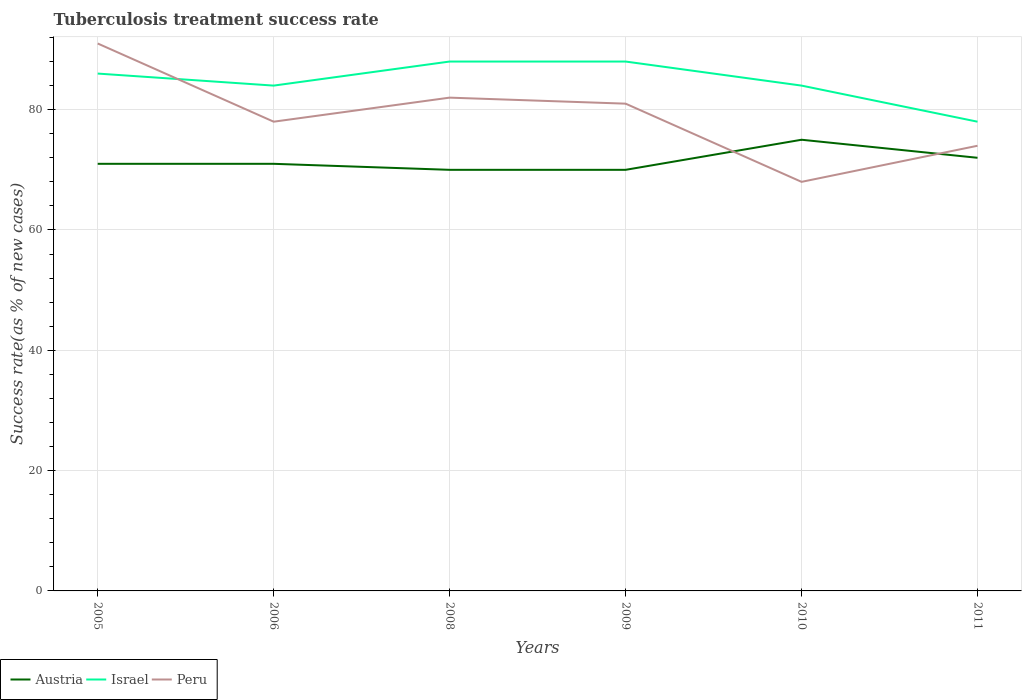How many different coloured lines are there?
Ensure brevity in your answer.  3. Does the line corresponding to Israel intersect with the line corresponding to Peru?
Your answer should be compact. Yes. Across all years, what is the maximum tuberculosis treatment success rate in Peru?
Offer a terse response. 68. In which year was the tuberculosis treatment success rate in Israel maximum?
Make the answer very short. 2011. What is the total tuberculosis treatment success rate in Peru in the graph?
Your answer should be compact. 23. What is the difference between the highest and the second highest tuberculosis treatment success rate in Israel?
Ensure brevity in your answer.  10. What is the difference between the highest and the lowest tuberculosis treatment success rate in Israel?
Ensure brevity in your answer.  3. Is the tuberculosis treatment success rate in Peru strictly greater than the tuberculosis treatment success rate in Israel over the years?
Offer a terse response. No. How many lines are there?
Make the answer very short. 3. How many years are there in the graph?
Offer a very short reply. 6. What is the difference between two consecutive major ticks on the Y-axis?
Make the answer very short. 20. Are the values on the major ticks of Y-axis written in scientific E-notation?
Offer a very short reply. No. Does the graph contain grids?
Provide a short and direct response. Yes. How are the legend labels stacked?
Offer a terse response. Horizontal. What is the title of the graph?
Give a very brief answer. Tuberculosis treatment success rate. What is the label or title of the Y-axis?
Keep it short and to the point. Success rate(as % of new cases). What is the Success rate(as % of new cases) of Peru in 2005?
Your response must be concise. 91. What is the Success rate(as % of new cases) of Peru in 2008?
Your response must be concise. 82. What is the Success rate(as % of new cases) in Austria in 2009?
Your response must be concise. 70. What is the Success rate(as % of new cases) in Israel in 2009?
Offer a terse response. 88. What is the Success rate(as % of new cases) in Austria in 2010?
Your response must be concise. 75. What is the Success rate(as % of new cases) of Israel in 2011?
Your response must be concise. 78. What is the Success rate(as % of new cases) of Peru in 2011?
Provide a succinct answer. 74. Across all years, what is the maximum Success rate(as % of new cases) in Austria?
Your response must be concise. 75. Across all years, what is the maximum Success rate(as % of new cases) of Peru?
Your answer should be very brief. 91. Across all years, what is the minimum Success rate(as % of new cases) in Austria?
Your answer should be compact. 70. What is the total Success rate(as % of new cases) in Austria in the graph?
Offer a terse response. 429. What is the total Success rate(as % of new cases) in Israel in the graph?
Keep it short and to the point. 508. What is the total Success rate(as % of new cases) of Peru in the graph?
Provide a short and direct response. 474. What is the difference between the Success rate(as % of new cases) in Austria in 2005 and that in 2006?
Provide a succinct answer. 0. What is the difference between the Success rate(as % of new cases) in Israel in 2005 and that in 2008?
Make the answer very short. -2. What is the difference between the Success rate(as % of new cases) in Austria in 2005 and that in 2009?
Give a very brief answer. 1. What is the difference between the Success rate(as % of new cases) of Israel in 2005 and that in 2009?
Give a very brief answer. -2. What is the difference between the Success rate(as % of new cases) of Peru in 2005 and that in 2009?
Provide a short and direct response. 10. What is the difference between the Success rate(as % of new cases) in Israel in 2005 and that in 2010?
Your answer should be very brief. 2. What is the difference between the Success rate(as % of new cases) in Peru in 2005 and that in 2010?
Make the answer very short. 23. What is the difference between the Success rate(as % of new cases) in Austria in 2005 and that in 2011?
Your answer should be compact. -1. What is the difference between the Success rate(as % of new cases) of Israel in 2005 and that in 2011?
Your answer should be compact. 8. What is the difference between the Success rate(as % of new cases) in Austria in 2006 and that in 2008?
Provide a short and direct response. 1. What is the difference between the Success rate(as % of new cases) of Israel in 2006 and that in 2008?
Your answer should be compact. -4. What is the difference between the Success rate(as % of new cases) of Peru in 2006 and that in 2008?
Keep it short and to the point. -4. What is the difference between the Success rate(as % of new cases) of Austria in 2006 and that in 2009?
Make the answer very short. 1. What is the difference between the Success rate(as % of new cases) of Israel in 2006 and that in 2009?
Provide a short and direct response. -4. What is the difference between the Success rate(as % of new cases) of Peru in 2006 and that in 2010?
Make the answer very short. 10. What is the difference between the Success rate(as % of new cases) in Israel in 2006 and that in 2011?
Offer a terse response. 6. What is the difference between the Success rate(as % of new cases) of Austria in 2008 and that in 2010?
Provide a short and direct response. -5. What is the difference between the Success rate(as % of new cases) of Israel in 2008 and that in 2010?
Ensure brevity in your answer.  4. What is the difference between the Success rate(as % of new cases) of Peru in 2008 and that in 2011?
Provide a succinct answer. 8. What is the difference between the Success rate(as % of new cases) of Austria in 2009 and that in 2011?
Provide a short and direct response. -2. What is the difference between the Success rate(as % of new cases) of Austria in 2005 and the Success rate(as % of new cases) of Israel in 2006?
Give a very brief answer. -13. What is the difference between the Success rate(as % of new cases) in Austria in 2005 and the Success rate(as % of new cases) in Peru in 2006?
Give a very brief answer. -7. What is the difference between the Success rate(as % of new cases) in Israel in 2005 and the Success rate(as % of new cases) in Peru in 2006?
Your answer should be compact. 8. What is the difference between the Success rate(as % of new cases) of Austria in 2005 and the Success rate(as % of new cases) of Peru in 2008?
Give a very brief answer. -11. What is the difference between the Success rate(as % of new cases) of Israel in 2005 and the Success rate(as % of new cases) of Peru in 2008?
Your answer should be very brief. 4. What is the difference between the Success rate(as % of new cases) in Austria in 2005 and the Success rate(as % of new cases) in Israel in 2009?
Ensure brevity in your answer.  -17. What is the difference between the Success rate(as % of new cases) in Austria in 2005 and the Success rate(as % of new cases) in Peru in 2010?
Your answer should be compact. 3. What is the difference between the Success rate(as % of new cases) in Israel in 2005 and the Success rate(as % of new cases) in Peru in 2010?
Your response must be concise. 18. What is the difference between the Success rate(as % of new cases) of Israel in 2005 and the Success rate(as % of new cases) of Peru in 2011?
Your answer should be very brief. 12. What is the difference between the Success rate(as % of new cases) in Austria in 2006 and the Success rate(as % of new cases) in Israel in 2008?
Make the answer very short. -17. What is the difference between the Success rate(as % of new cases) in Austria in 2006 and the Success rate(as % of new cases) in Israel in 2009?
Give a very brief answer. -17. What is the difference between the Success rate(as % of new cases) of Austria in 2006 and the Success rate(as % of new cases) of Peru in 2009?
Offer a terse response. -10. What is the difference between the Success rate(as % of new cases) in Israel in 2006 and the Success rate(as % of new cases) in Peru in 2009?
Ensure brevity in your answer.  3. What is the difference between the Success rate(as % of new cases) of Austria in 2006 and the Success rate(as % of new cases) of Israel in 2010?
Provide a short and direct response. -13. What is the difference between the Success rate(as % of new cases) in Israel in 2006 and the Success rate(as % of new cases) in Peru in 2010?
Keep it short and to the point. 16. What is the difference between the Success rate(as % of new cases) in Austria in 2006 and the Success rate(as % of new cases) in Israel in 2011?
Offer a terse response. -7. What is the difference between the Success rate(as % of new cases) in Israel in 2008 and the Success rate(as % of new cases) in Peru in 2009?
Provide a succinct answer. 7. What is the difference between the Success rate(as % of new cases) of Israel in 2008 and the Success rate(as % of new cases) of Peru in 2011?
Offer a very short reply. 14. What is the difference between the Success rate(as % of new cases) of Austria in 2009 and the Success rate(as % of new cases) of Israel in 2010?
Offer a very short reply. -14. What is the difference between the Success rate(as % of new cases) of Austria in 2009 and the Success rate(as % of new cases) of Peru in 2010?
Keep it short and to the point. 2. What is the difference between the Success rate(as % of new cases) in Israel in 2009 and the Success rate(as % of new cases) in Peru in 2010?
Provide a succinct answer. 20. What is the difference between the Success rate(as % of new cases) of Israel in 2009 and the Success rate(as % of new cases) of Peru in 2011?
Give a very brief answer. 14. What is the difference between the Success rate(as % of new cases) of Austria in 2010 and the Success rate(as % of new cases) of Israel in 2011?
Give a very brief answer. -3. What is the difference between the Success rate(as % of new cases) in Austria in 2010 and the Success rate(as % of new cases) in Peru in 2011?
Offer a very short reply. 1. What is the difference between the Success rate(as % of new cases) in Israel in 2010 and the Success rate(as % of new cases) in Peru in 2011?
Offer a very short reply. 10. What is the average Success rate(as % of new cases) of Austria per year?
Offer a very short reply. 71.5. What is the average Success rate(as % of new cases) of Israel per year?
Give a very brief answer. 84.67. What is the average Success rate(as % of new cases) in Peru per year?
Provide a succinct answer. 79. In the year 2005, what is the difference between the Success rate(as % of new cases) of Austria and Success rate(as % of new cases) of Israel?
Provide a succinct answer. -15. In the year 2005, what is the difference between the Success rate(as % of new cases) in Austria and Success rate(as % of new cases) in Peru?
Your answer should be very brief. -20. In the year 2005, what is the difference between the Success rate(as % of new cases) of Israel and Success rate(as % of new cases) of Peru?
Your answer should be compact. -5. In the year 2006, what is the difference between the Success rate(as % of new cases) of Austria and Success rate(as % of new cases) of Israel?
Your response must be concise. -13. In the year 2008, what is the difference between the Success rate(as % of new cases) of Israel and Success rate(as % of new cases) of Peru?
Keep it short and to the point. 6. In the year 2009, what is the difference between the Success rate(as % of new cases) of Austria and Success rate(as % of new cases) of Israel?
Your answer should be compact. -18. In the year 2009, what is the difference between the Success rate(as % of new cases) in Austria and Success rate(as % of new cases) in Peru?
Make the answer very short. -11. In the year 2010, what is the difference between the Success rate(as % of new cases) of Austria and Success rate(as % of new cases) of Israel?
Offer a very short reply. -9. In the year 2010, what is the difference between the Success rate(as % of new cases) in Austria and Success rate(as % of new cases) in Peru?
Keep it short and to the point. 7. In the year 2011, what is the difference between the Success rate(as % of new cases) in Austria and Success rate(as % of new cases) in Israel?
Ensure brevity in your answer.  -6. What is the ratio of the Success rate(as % of new cases) of Israel in 2005 to that in 2006?
Offer a terse response. 1.02. What is the ratio of the Success rate(as % of new cases) in Austria in 2005 to that in 2008?
Make the answer very short. 1.01. What is the ratio of the Success rate(as % of new cases) in Israel in 2005 to that in 2008?
Give a very brief answer. 0.98. What is the ratio of the Success rate(as % of new cases) of Peru in 2005 to that in 2008?
Your answer should be very brief. 1.11. What is the ratio of the Success rate(as % of new cases) of Austria in 2005 to that in 2009?
Provide a succinct answer. 1.01. What is the ratio of the Success rate(as % of new cases) of Israel in 2005 to that in 2009?
Give a very brief answer. 0.98. What is the ratio of the Success rate(as % of new cases) of Peru in 2005 to that in 2009?
Give a very brief answer. 1.12. What is the ratio of the Success rate(as % of new cases) in Austria in 2005 to that in 2010?
Provide a succinct answer. 0.95. What is the ratio of the Success rate(as % of new cases) in Israel in 2005 to that in 2010?
Your response must be concise. 1.02. What is the ratio of the Success rate(as % of new cases) in Peru in 2005 to that in 2010?
Your answer should be compact. 1.34. What is the ratio of the Success rate(as % of new cases) in Austria in 2005 to that in 2011?
Provide a succinct answer. 0.99. What is the ratio of the Success rate(as % of new cases) of Israel in 2005 to that in 2011?
Provide a short and direct response. 1.1. What is the ratio of the Success rate(as % of new cases) in Peru in 2005 to that in 2011?
Provide a succinct answer. 1.23. What is the ratio of the Success rate(as % of new cases) in Austria in 2006 to that in 2008?
Provide a succinct answer. 1.01. What is the ratio of the Success rate(as % of new cases) of Israel in 2006 to that in 2008?
Your answer should be compact. 0.95. What is the ratio of the Success rate(as % of new cases) of Peru in 2006 to that in 2008?
Make the answer very short. 0.95. What is the ratio of the Success rate(as % of new cases) of Austria in 2006 to that in 2009?
Keep it short and to the point. 1.01. What is the ratio of the Success rate(as % of new cases) of Israel in 2006 to that in 2009?
Your answer should be compact. 0.95. What is the ratio of the Success rate(as % of new cases) in Peru in 2006 to that in 2009?
Provide a succinct answer. 0.96. What is the ratio of the Success rate(as % of new cases) of Austria in 2006 to that in 2010?
Make the answer very short. 0.95. What is the ratio of the Success rate(as % of new cases) of Peru in 2006 to that in 2010?
Ensure brevity in your answer.  1.15. What is the ratio of the Success rate(as % of new cases) in Austria in 2006 to that in 2011?
Provide a succinct answer. 0.99. What is the ratio of the Success rate(as % of new cases) in Israel in 2006 to that in 2011?
Offer a terse response. 1.08. What is the ratio of the Success rate(as % of new cases) in Peru in 2006 to that in 2011?
Provide a succinct answer. 1.05. What is the ratio of the Success rate(as % of new cases) in Austria in 2008 to that in 2009?
Offer a very short reply. 1. What is the ratio of the Success rate(as % of new cases) in Israel in 2008 to that in 2009?
Offer a very short reply. 1. What is the ratio of the Success rate(as % of new cases) in Peru in 2008 to that in 2009?
Offer a very short reply. 1.01. What is the ratio of the Success rate(as % of new cases) in Israel in 2008 to that in 2010?
Offer a very short reply. 1.05. What is the ratio of the Success rate(as % of new cases) in Peru in 2008 to that in 2010?
Keep it short and to the point. 1.21. What is the ratio of the Success rate(as % of new cases) in Austria in 2008 to that in 2011?
Offer a terse response. 0.97. What is the ratio of the Success rate(as % of new cases) in Israel in 2008 to that in 2011?
Offer a very short reply. 1.13. What is the ratio of the Success rate(as % of new cases) in Peru in 2008 to that in 2011?
Keep it short and to the point. 1.11. What is the ratio of the Success rate(as % of new cases) in Austria in 2009 to that in 2010?
Your response must be concise. 0.93. What is the ratio of the Success rate(as % of new cases) of Israel in 2009 to that in 2010?
Provide a succinct answer. 1.05. What is the ratio of the Success rate(as % of new cases) of Peru in 2009 to that in 2010?
Provide a succinct answer. 1.19. What is the ratio of the Success rate(as % of new cases) of Austria in 2009 to that in 2011?
Make the answer very short. 0.97. What is the ratio of the Success rate(as % of new cases) in Israel in 2009 to that in 2011?
Provide a succinct answer. 1.13. What is the ratio of the Success rate(as % of new cases) of Peru in 2009 to that in 2011?
Ensure brevity in your answer.  1.09. What is the ratio of the Success rate(as % of new cases) of Austria in 2010 to that in 2011?
Provide a succinct answer. 1.04. What is the ratio of the Success rate(as % of new cases) in Peru in 2010 to that in 2011?
Provide a succinct answer. 0.92. What is the difference between the highest and the second highest Success rate(as % of new cases) in Austria?
Make the answer very short. 3. 